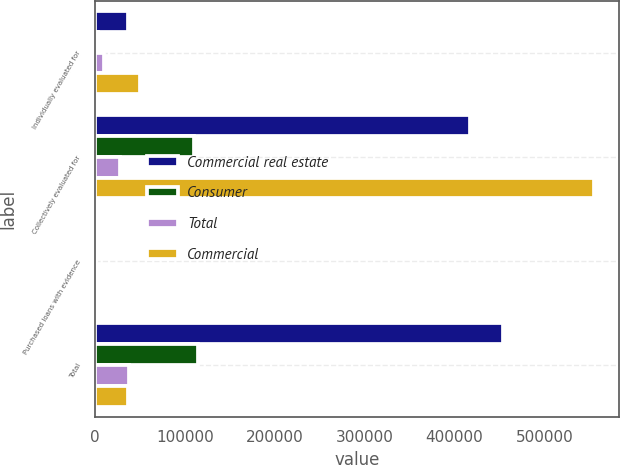<chart> <loc_0><loc_0><loc_500><loc_500><stacked_bar_chart><ecel><fcel>Individually evaluated for<fcel>Collectively evaluated for<fcel>Purchased loans with evidence<fcel>Total<nl><fcel>Commercial real estate<fcel>36909<fcel>417295<fcel>73<fcel>454277<nl><fcel>Consumer<fcel>3154<fcel>110417<fcel>421<fcel>113992<nl><fcel>Total<fcel>9462<fcel>27866<fcel>451<fcel>37779<nl><fcel>Commercial<fcel>49525<fcel>555578<fcel>945<fcel>36909<nl></chart> 